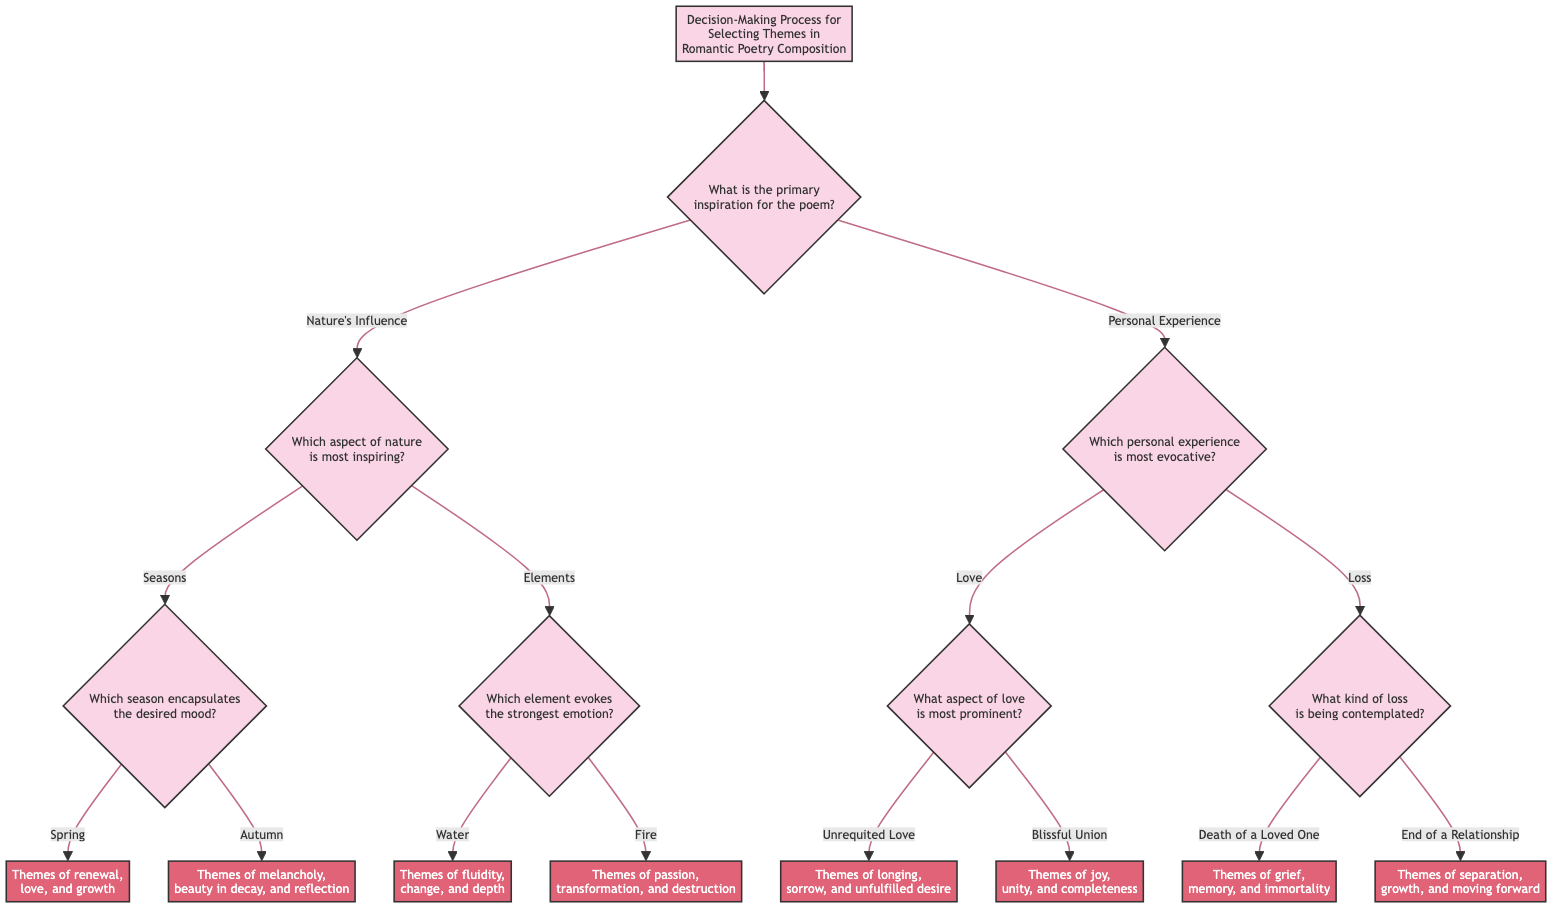What is the primary question at the root of the decision tree? The root question at the top of the decision tree is "What is the primary inspiration for the poem?" which is the starting point for the decision-making process.
Answer: What is the primary inspiration for the poem? How many main branches extend from the primary inspiration question? There are two main branches stemming from the question, which are "Nature’s Influence" and "Personal Experience." This helps to categorize the sources of inspiration into two distinct areas.
Answer: 2 What theme is associated with the aspect "Spring"? The aspect "Spring" leads to the endpoint "Themes of renewal, love, and growth," which reflects the emotions and ideas typically conveyed in poetry about this season.
Answer: Themes of renewal, love, and growth Which personal experience category involves contemplating the "Death of a Loved One"? The category "Loss" encompasses the experience of contemplating the "Death of a Loved One," which pertains to the theme of dealing with grief and memory.
Answer: Loss What themes arise from the condition of "Unrequited Love"? The condition of "Unrequited Love" leads to the endpoint "Themes of longing, sorrow, and unfulfilled desire," illustrating the emotional turmoil related to this type of love.
Answer: Themes of longing, sorrow, and unfulfilled desire What question follows the condition "Elements" in the decision-making process? After identifying "Elements" as inspiring in nature, the next question posed is "Which element evokes the strongest emotion?" This guides further exploration into specific natural elements.
Answer: Which element evokes the strongest emotion? How many endpoints are there under "Love"? Under the "Love" condition, there are two endpoints: "Themes of longing, sorrow, and unfulfilled desire" (for Unrequited Love) and "Themes of joy, unity, and completeness" (for Blissful Union). Thus, there are two unique outcomes associated with love.
Answer: 2 What are the themes related to "Autumn"? The condition "Autumn" leads to the endpoint "Themes of melancholy, beauty in decay, and reflection," representing the various emotional and thematic elements related to this season.
Answer: Themes of melancholy, beauty in decay, and reflection What decision leads to themes of "passion, transformation, and destruction"? The decision branch that leads to "passion, transformation, and destruction" is from the element "Fire," indicating the emotional intensity associated with this natural element in romantic poetry.
Answer: Themes of passion, transformation, and destruction 